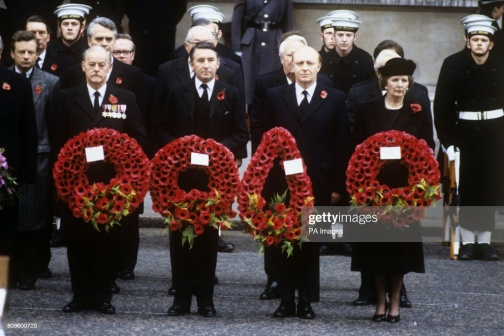Write a detailed description of the given image. In the image, a solemn gathering is taking place, likely a memorial service or commemoration. A group of individuals are standing side by side, each holding a large wreath composed of vibrant red poppy flowers. The vivid red flowers form a striking visual element, symbolizing remembrance. Each wreath is circular in shape, embellished with a prominent red ribbon at the bottom, except for the wreath held by the person on the far left, which is distinguished by a yellow ribbon. The participants are dressed in formal attire; some are in black suits and coats while others are in military uniforms complete with hats, indicating their possible involvement in a military or state ceremony. Their serious expressions and the dignified, respectful stance of each individual highlight the gravity of the event. The backdrop, a gray building with a bare, functional design featuring windows and a black railing, adds to the somber atmosphere. The stark contrast between the bright red wreaths and the austere background emphasizes the poignant nature of the occasion. The image vividly captures a moment of collective remembrance and respect. 